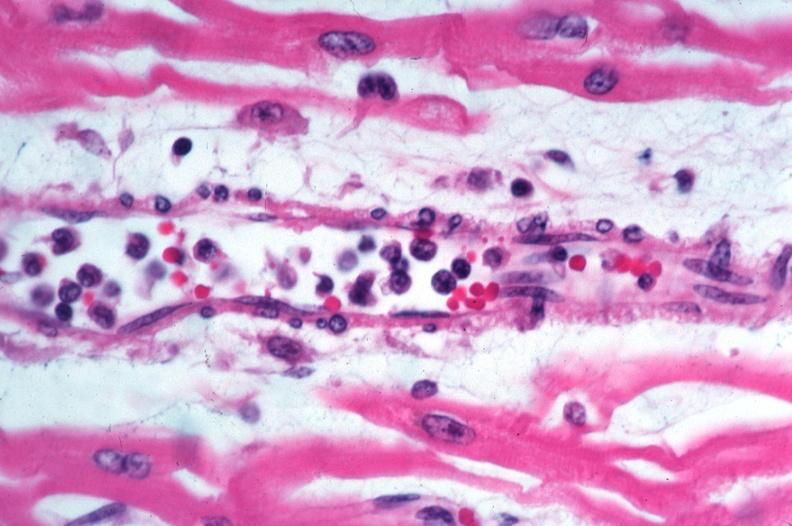what does this image show?
Answer the question using a single word or phrase. Skin 